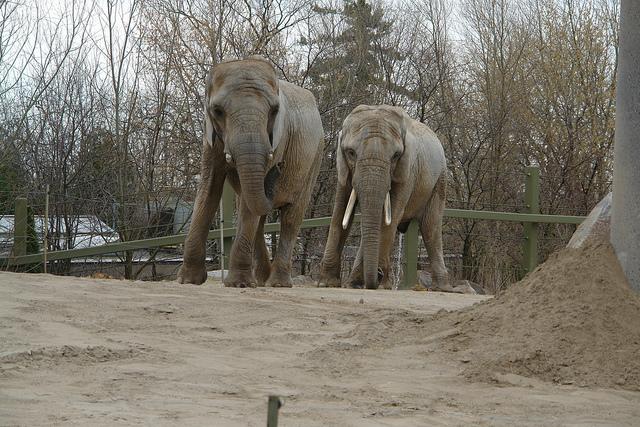Are they mother and son?
Concise answer only. Yes. What animal is this?
Keep it brief. Elephant. Where are these elephants?
Give a very brief answer. Zoo. Are the animals walking?
Keep it brief. Yes. 